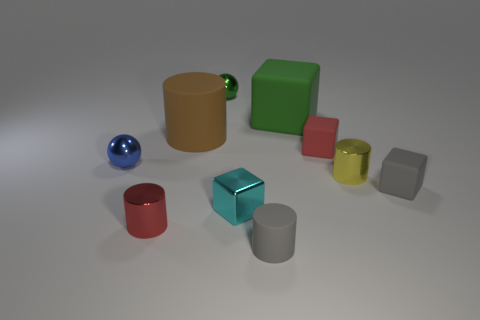Subtract all brown cylinders. How many cylinders are left? 3 Subtract all gray blocks. How many blocks are left? 3 Subtract 4 cubes. How many cubes are left? 0 Subtract all spheres. How many objects are left? 8 Subtract all gray blocks. How many cyan balls are left? 0 Add 5 green metal spheres. How many green metal spheres are left? 6 Add 4 big green shiny balls. How many big green shiny balls exist? 4 Subtract 1 blue spheres. How many objects are left? 9 Subtract all gray cylinders. Subtract all blue blocks. How many cylinders are left? 3 Subtract all small matte things. Subtract all gray objects. How many objects are left? 5 